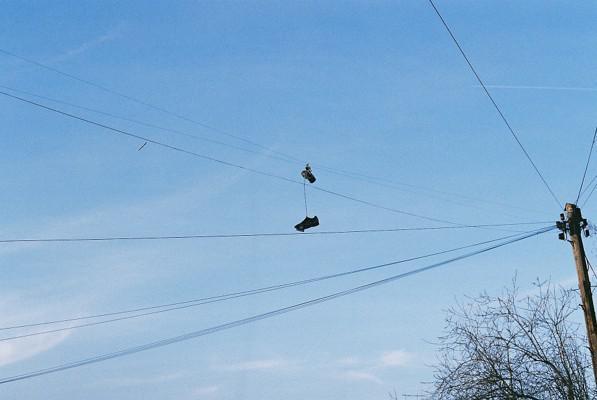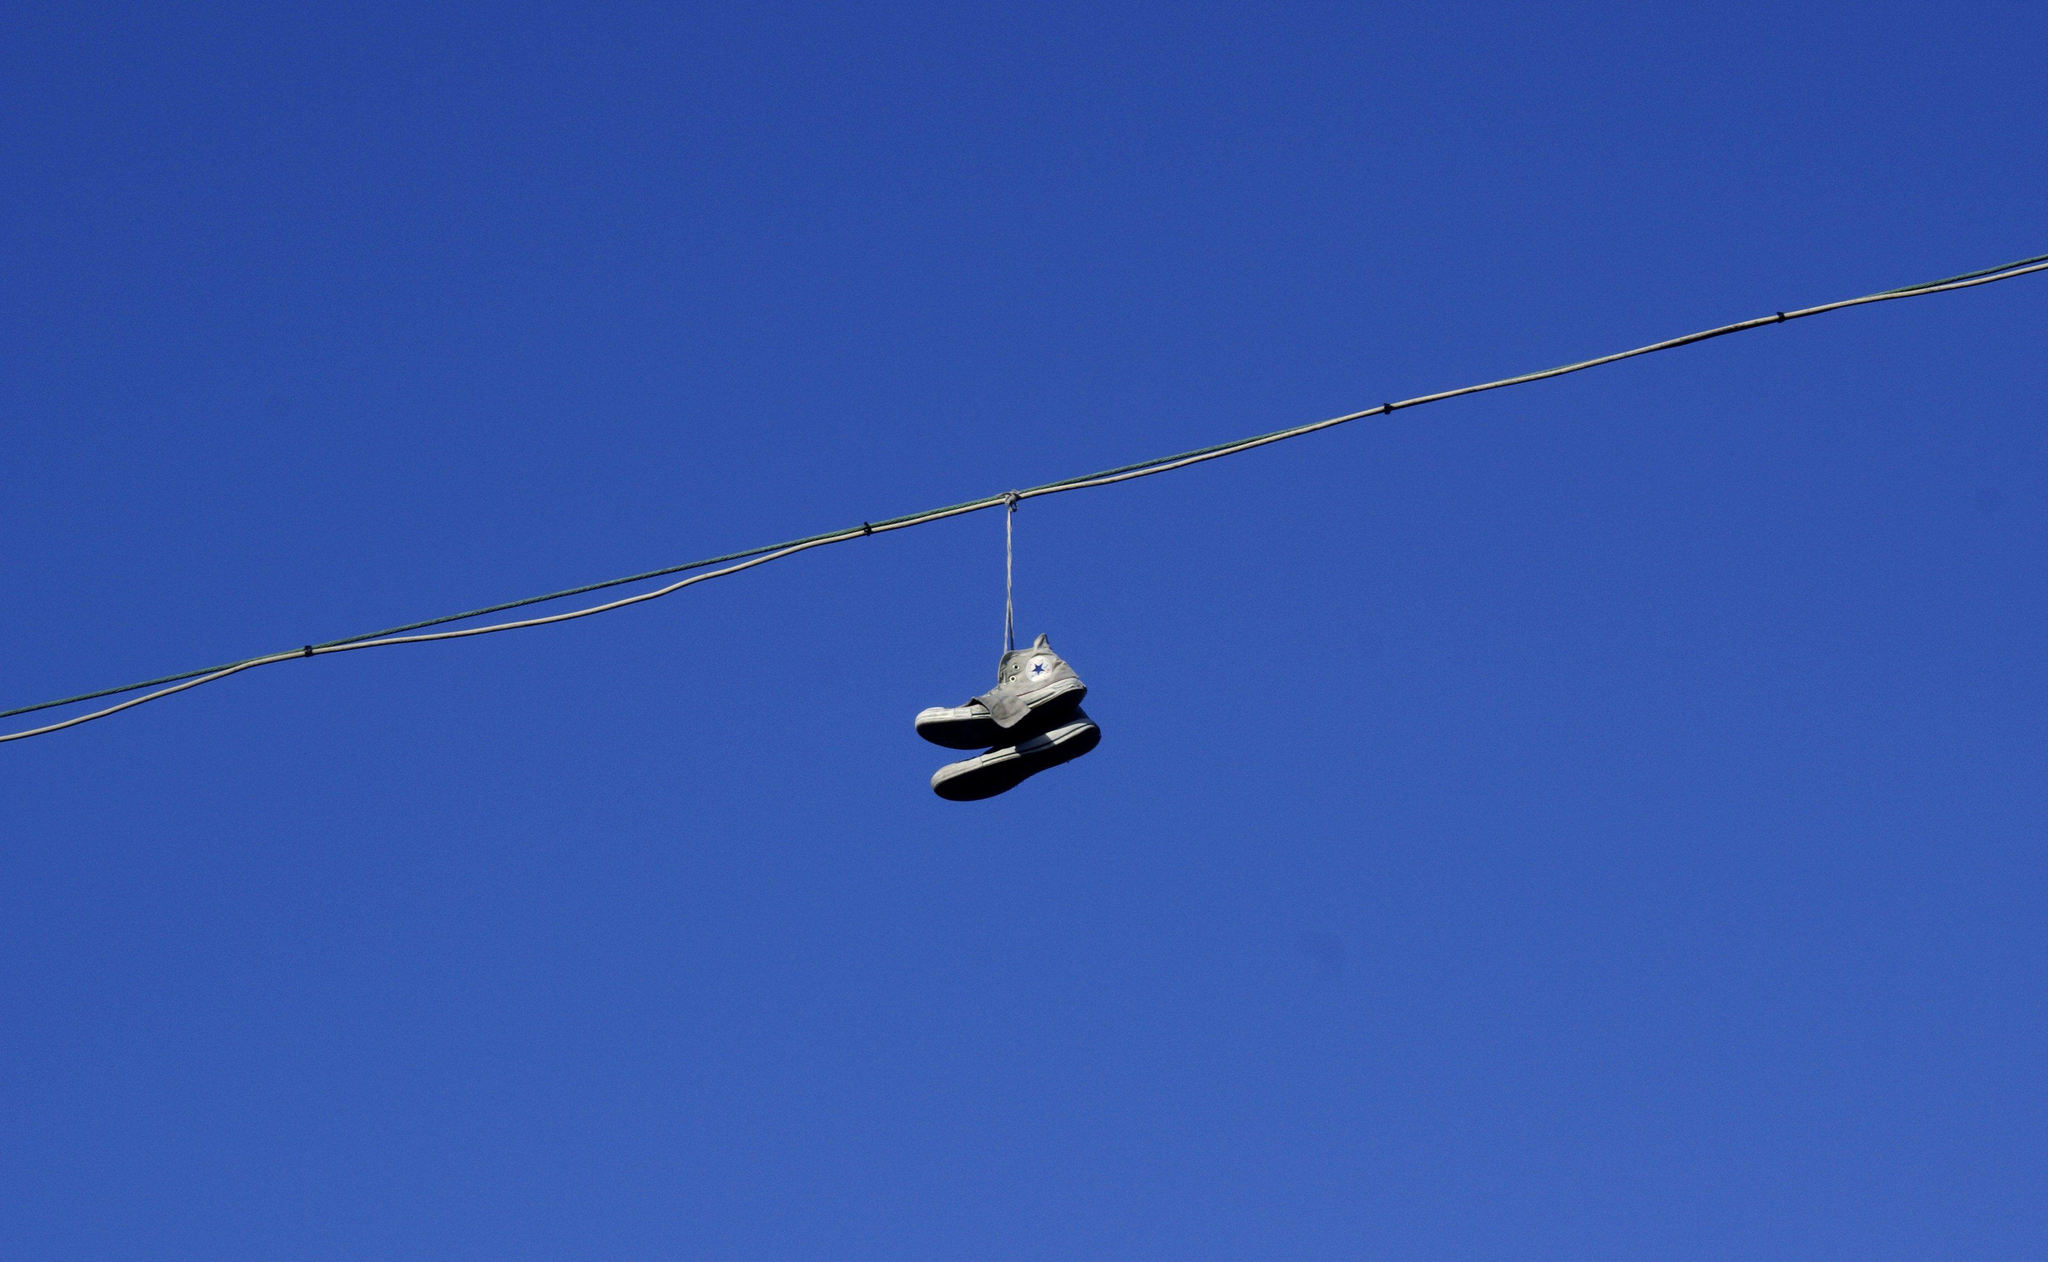The first image is the image on the left, the second image is the image on the right. Given the left and right images, does the statement "Multiple pairs of shoes are hanging from the power lines in at least one picture." hold true? Answer yes or no. No. The first image is the image on the left, the second image is the image on the right. Evaluate the accuracy of this statement regarding the images: "There are no more than 2 pairs of shoes hanging from a power line.". Is it true? Answer yes or no. Yes. 